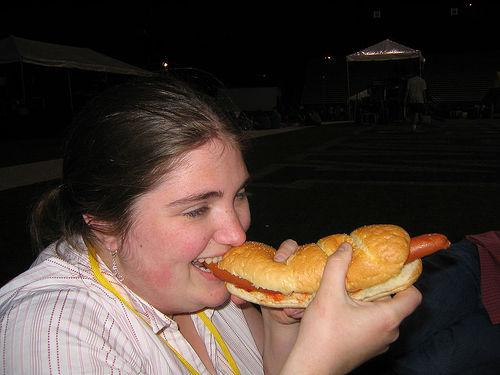Question: what color is the woman's shirt?
Choices:
A. Grey with stripes.
B. White with stripes.
C. Black with stripes.
D. Red with stripes.
Answer with the letter. Answer: B Question: when was this photo taken?
Choices:
A. Yesterday.
B. Today.
C. Midnight.
D. At night.
Answer with the letter. Answer: D 